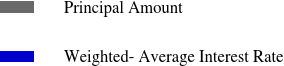<chart> <loc_0><loc_0><loc_500><loc_500><pie_chart><fcel>Principal Amount<fcel>Weighted- Average Interest Rate<nl><fcel>100.0%<fcel>0.0%<nl></chart> 